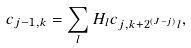<formula> <loc_0><loc_0><loc_500><loc_500>c _ { j - 1 , k } = \sum _ { l } H _ { l } c _ { j , k + 2 ^ { ( J - j ) } l } ,</formula> 